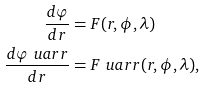Convert formula to latex. <formula><loc_0><loc_0><loc_500><loc_500>\frac { d \varphi } { d r } & = F ( r , \phi , \lambda ) \\ \frac { d \varphi ^ { \ } u a r r } { d r } & = F ^ { \ } u a r r ( r , \phi , \lambda ) ,</formula> 